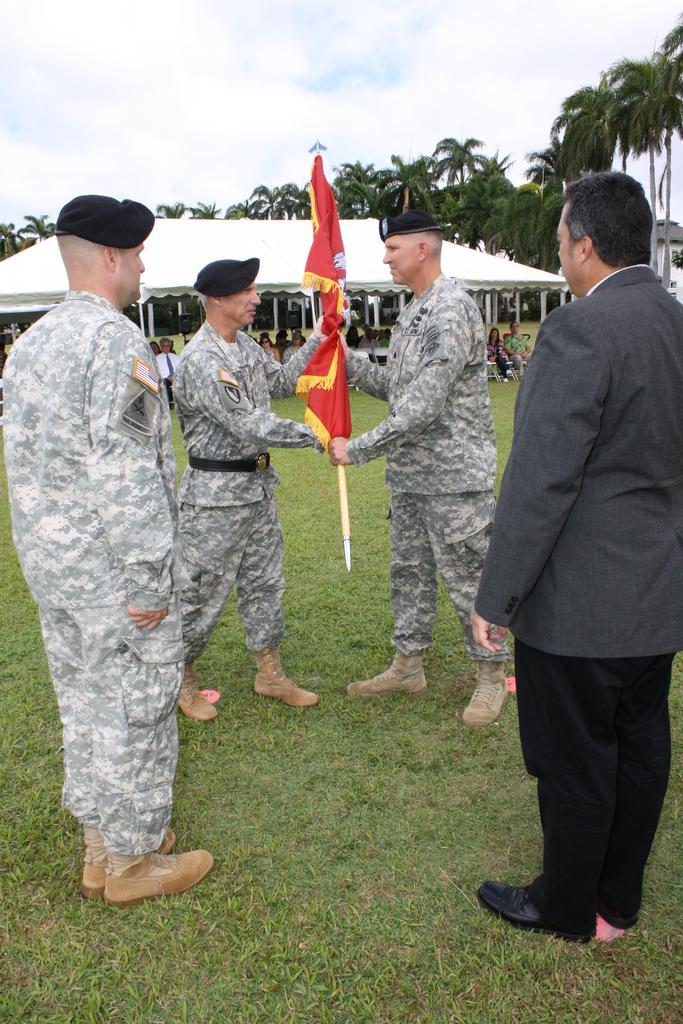Could you give a brief overview of what you see in this image? In this picture I can see people standing on the green grass. I can see two people holding the flag. I can people sitting in the background. I can see trees in the background. I can see clouds in the sky. 